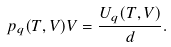Convert formula to latex. <formula><loc_0><loc_0><loc_500><loc_500>p _ { q } ( T , V ) V = \frac { U _ { q } ( T , V ) } { d } .</formula> 